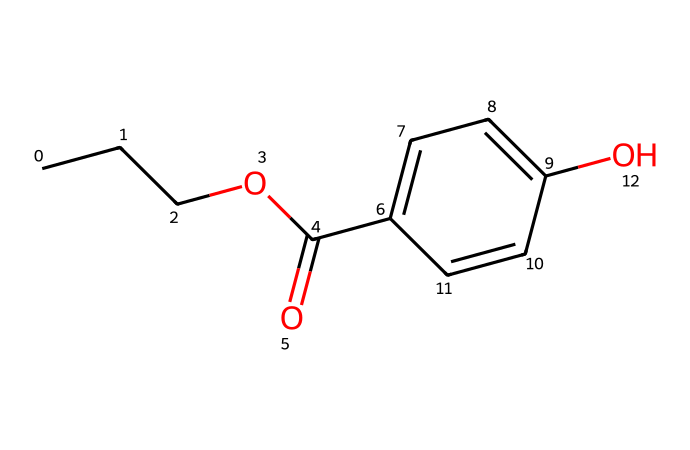What is the molecular formula of propylparaben? The molecular formula can be determined by counting the atoms of each element in the structure. For propylparaben, there are 10 carbon atoms, 12 hydrogen atoms, and 4 oxygen atoms, leading to the molecular formula C10H12O4.
Answer: C10H12O4 How many rings are present in the structure of propylparaben? By analyzing the structure, we find that there is one cyclic part in the molecule, which is a benzene ring. To confirm, we can identify that a ring is formed by the six carbon atoms in a cycle.
Answer: 1 What type of functional group is present in propylparaben? The structure contains an ester functional group as indicated by the C(=O)O linkage as well as a phenolic hydroxyl group (an -OH on the aromatic ring), both typical in preservative molecules.
Answer: ester and phenolic Which elements are found in the propylparaben molecule? By inspecting the structure, we can identify the elements present: carbon (C), hydrogen (H), and oxygen (O). These are the only atoms represented in the chemical's structure.
Answer: carbon, hydrogen, oxygen What is the purpose of propylparaben in personal care products? Propylparaben acts as a preservative, which helps to prevent the growth of bacteria and mold, thereby extending the shelf life of products. Its efficacy stems from its ability to inhibit microbial growth.
Answer: preservative How does the presence of a hydroxyl group in propylparaben contribute to its activity? The hydroxyl group (-OH) contributes to the molecule's ability to interact with other molecules and can enhance its antimicrobial properties. This functional group is crucial for the molecule's overall effectiveness as a preservative.
Answer: enhances antimicrobial properties 